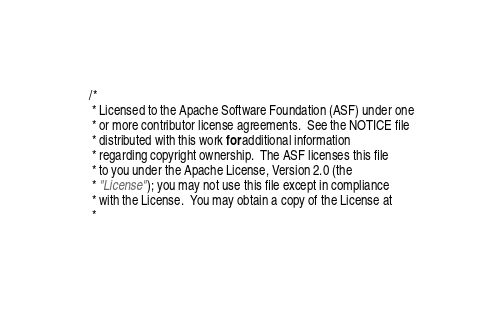<code> <loc_0><loc_0><loc_500><loc_500><_Go_>/*
 * Licensed to the Apache Software Foundation (ASF) under one
 * or more contributor license agreements.  See the NOTICE file
 * distributed with this work for additional information
 * regarding copyright ownership.  The ASF licenses this file
 * to you under the Apache License, Version 2.0 (the
 * "License"); you may not use this file except in compliance
 * with the License.  You may obtain a copy of the License at
 *</code> 